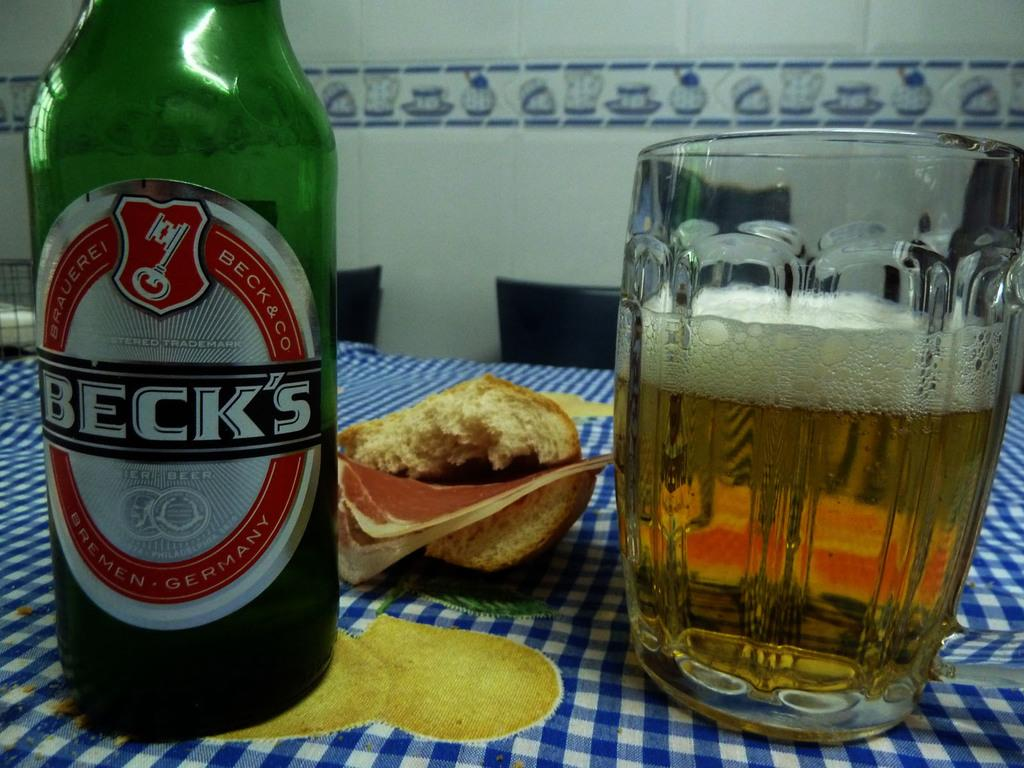What is the dog playing with in the image? The dog is playing with a ball in the image. Where is the ball located in the image? The ball is in the grass. What can be seen in the background of the image? There is a fence in the background of the image. What type of note is the dog holding in its mouth in the image? There is no note present in the image; the dog is playing with a ball. How many quinces are visible in the image? There are no quinces present in the image. 